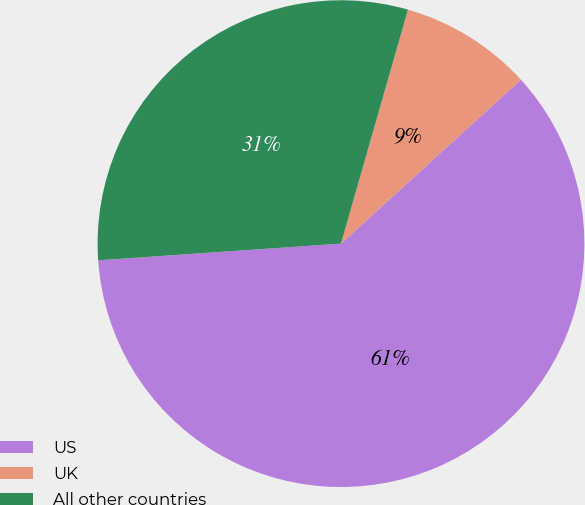<chart> <loc_0><loc_0><loc_500><loc_500><pie_chart><fcel>US<fcel>UK<fcel>All other countries<nl><fcel>60.67%<fcel>8.8%<fcel>30.53%<nl></chart> 